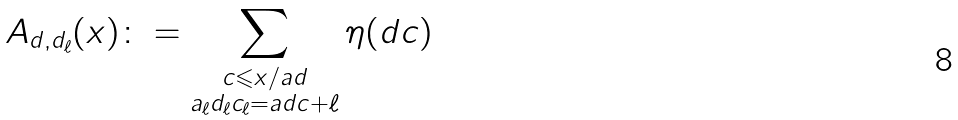<formula> <loc_0><loc_0><loc_500><loc_500>A _ { d , d _ { \ell } } ( x ) \colon = \sum _ { \substack { c \leqslant x / a d \\ a _ { \ell } d _ { \ell } c _ { \ell } = a d c + \ell } } \eta ( d c )</formula> 